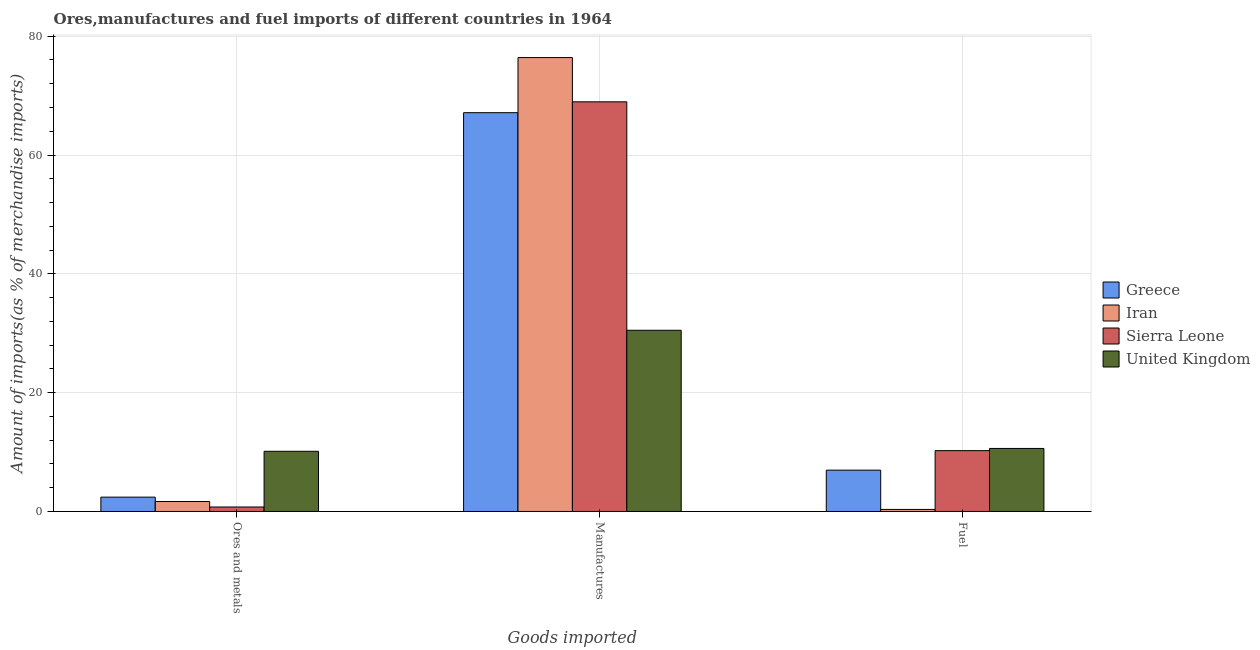How many different coloured bars are there?
Your answer should be compact. 4. How many groups of bars are there?
Your response must be concise. 3. How many bars are there on the 2nd tick from the left?
Your answer should be very brief. 4. How many bars are there on the 2nd tick from the right?
Your response must be concise. 4. What is the label of the 2nd group of bars from the left?
Provide a short and direct response. Manufactures. What is the percentage of fuel imports in Sierra Leone?
Provide a succinct answer. 10.24. Across all countries, what is the maximum percentage of fuel imports?
Provide a succinct answer. 10.61. Across all countries, what is the minimum percentage of manufactures imports?
Offer a very short reply. 30.5. In which country was the percentage of ores and metals imports minimum?
Offer a terse response. Sierra Leone. What is the total percentage of manufactures imports in the graph?
Offer a terse response. 243. What is the difference between the percentage of fuel imports in United Kingdom and that in Greece?
Keep it short and to the point. 3.65. What is the difference between the percentage of fuel imports in Sierra Leone and the percentage of ores and metals imports in United Kingdom?
Make the answer very short. 0.11. What is the average percentage of fuel imports per country?
Your answer should be very brief. 7.04. What is the difference between the percentage of manufactures imports and percentage of fuel imports in Iran?
Offer a terse response. 76.06. What is the ratio of the percentage of ores and metals imports in Greece to that in United Kingdom?
Your answer should be compact. 0.24. Is the percentage of fuel imports in Greece less than that in Iran?
Your answer should be very brief. No. Is the difference between the percentage of fuel imports in United Kingdom and Greece greater than the difference between the percentage of ores and metals imports in United Kingdom and Greece?
Make the answer very short. No. What is the difference between the highest and the second highest percentage of ores and metals imports?
Provide a succinct answer. 7.72. What is the difference between the highest and the lowest percentage of manufactures imports?
Your answer should be very brief. 45.9. What does the 4th bar from the left in Ores and metals represents?
Provide a succinct answer. United Kingdom. What does the 1st bar from the right in Ores and metals represents?
Provide a succinct answer. United Kingdom. Is it the case that in every country, the sum of the percentage of ores and metals imports and percentage of manufactures imports is greater than the percentage of fuel imports?
Give a very brief answer. Yes. How many countries are there in the graph?
Provide a short and direct response. 4. What is the difference between two consecutive major ticks on the Y-axis?
Offer a terse response. 20. Are the values on the major ticks of Y-axis written in scientific E-notation?
Give a very brief answer. No. Does the graph contain any zero values?
Your response must be concise. No. Does the graph contain grids?
Your answer should be very brief. Yes. How are the legend labels stacked?
Your answer should be very brief. Vertical. What is the title of the graph?
Make the answer very short. Ores,manufactures and fuel imports of different countries in 1964. What is the label or title of the X-axis?
Offer a very short reply. Goods imported. What is the label or title of the Y-axis?
Ensure brevity in your answer.  Amount of imports(as % of merchandise imports). What is the Amount of imports(as % of merchandise imports) in Greece in Ores and metals?
Offer a very short reply. 2.42. What is the Amount of imports(as % of merchandise imports) in Iran in Ores and metals?
Provide a succinct answer. 1.68. What is the Amount of imports(as % of merchandise imports) in Sierra Leone in Ores and metals?
Your answer should be compact. 0.76. What is the Amount of imports(as % of merchandise imports) of United Kingdom in Ores and metals?
Give a very brief answer. 10.13. What is the Amount of imports(as % of merchandise imports) of Greece in Manufactures?
Your answer should be compact. 67.13. What is the Amount of imports(as % of merchandise imports) of Iran in Manufactures?
Offer a very short reply. 76.41. What is the Amount of imports(as % of merchandise imports) in Sierra Leone in Manufactures?
Ensure brevity in your answer.  68.96. What is the Amount of imports(as % of merchandise imports) in United Kingdom in Manufactures?
Your answer should be very brief. 30.5. What is the Amount of imports(as % of merchandise imports) in Greece in Fuel?
Your response must be concise. 6.96. What is the Amount of imports(as % of merchandise imports) in Iran in Fuel?
Give a very brief answer. 0.35. What is the Amount of imports(as % of merchandise imports) of Sierra Leone in Fuel?
Provide a succinct answer. 10.24. What is the Amount of imports(as % of merchandise imports) of United Kingdom in Fuel?
Your response must be concise. 10.61. Across all Goods imported, what is the maximum Amount of imports(as % of merchandise imports) of Greece?
Your answer should be very brief. 67.13. Across all Goods imported, what is the maximum Amount of imports(as % of merchandise imports) of Iran?
Keep it short and to the point. 76.41. Across all Goods imported, what is the maximum Amount of imports(as % of merchandise imports) of Sierra Leone?
Offer a terse response. 68.96. Across all Goods imported, what is the maximum Amount of imports(as % of merchandise imports) in United Kingdom?
Your response must be concise. 30.5. Across all Goods imported, what is the minimum Amount of imports(as % of merchandise imports) in Greece?
Ensure brevity in your answer.  2.42. Across all Goods imported, what is the minimum Amount of imports(as % of merchandise imports) of Iran?
Make the answer very short. 0.35. Across all Goods imported, what is the minimum Amount of imports(as % of merchandise imports) in Sierra Leone?
Provide a succinct answer. 0.76. Across all Goods imported, what is the minimum Amount of imports(as % of merchandise imports) of United Kingdom?
Offer a very short reply. 10.13. What is the total Amount of imports(as % of merchandise imports) of Greece in the graph?
Ensure brevity in your answer.  76.5. What is the total Amount of imports(as % of merchandise imports) in Iran in the graph?
Ensure brevity in your answer.  78.44. What is the total Amount of imports(as % of merchandise imports) in Sierra Leone in the graph?
Your answer should be very brief. 79.96. What is the total Amount of imports(as % of merchandise imports) of United Kingdom in the graph?
Your answer should be compact. 51.25. What is the difference between the Amount of imports(as % of merchandise imports) in Greece in Ores and metals and that in Manufactures?
Provide a short and direct response. -64.71. What is the difference between the Amount of imports(as % of merchandise imports) in Iran in Ores and metals and that in Manufactures?
Offer a very short reply. -74.72. What is the difference between the Amount of imports(as % of merchandise imports) of Sierra Leone in Ores and metals and that in Manufactures?
Provide a succinct answer. -68.2. What is the difference between the Amount of imports(as % of merchandise imports) of United Kingdom in Ores and metals and that in Manufactures?
Make the answer very short. -20.37. What is the difference between the Amount of imports(as % of merchandise imports) in Greece in Ores and metals and that in Fuel?
Offer a very short reply. -4.54. What is the difference between the Amount of imports(as % of merchandise imports) in Iran in Ores and metals and that in Fuel?
Your response must be concise. 1.34. What is the difference between the Amount of imports(as % of merchandise imports) of Sierra Leone in Ores and metals and that in Fuel?
Provide a succinct answer. -9.49. What is the difference between the Amount of imports(as % of merchandise imports) of United Kingdom in Ores and metals and that in Fuel?
Offer a terse response. -0.48. What is the difference between the Amount of imports(as % of merchandise imports) of Greece in Manufactures and that in Fuel?
Make the answer very short. 60.17. What is the difference between the Amount of imports(as % of merchandise imports) of Iran in Manufactures and that in Fuel?
Your response must be concise. 76.06. What is the difference between the Amount of imports(as % of merchandise imports) in Sierra Leone in Manufactures and that in Fuel?
Keep it short and to the point. 58.72. What is the difference between the Amount of imports(as % of merchandise imports) of United Kingdom in Manufactures and that in Fuel?
Your answer should be compact. 19.89. What is the difference between the Amount of imports(as % of merchandise imports) of Greece in Ores and metals and the Amount of imports(as % of merchandise imports) of Iran in Manufactures?
Ensure brevity in your answer.  -73.99. What is the difference between the Amount of imports(as % of merchandise imports) in Greece in Ores and metals and the Amount of imports(as % of merchandise imports) in Sierra Leone in Manufactures?
Give a very brief answer. -66.54. What is the difference between the Amount of imports(as % of merchandise imports) in Greece in Ores and metals and the Amount of imports(as % of merchandise imports) in United Kingdom in Manufactures?
Provide a short and direct response. -28.09. What is the difference between the Amount of imports(as % of merchandise imports) of Iran in Ores and metals and the Amount of imports(as % of merchandise imports) of Sierra Leone in Manufactures?
Offer a terse response. -67.27. What is the difference between the Amount of imports(as % of merchandise imports) in Iran in Ores and metals and the Amount of imports(as % of merchandise imports) in United Kingdom in Manufactures?
Offer a very short reply. -28.82. What is the difference between the Amount of imports(as % of merchandise imports) of Sierra Leone in Ores and metals and the Amount of imports(as % of merchandise imports) of United Kingdom in Manufactures?
Keep it short and to the point. -29.75. What is the difference between the Amount of imports(as % of merchandise imports) of Greece in Ores and metals and the Amount of imports(as % of merchandise imports) of Iran in Fuel?
Give a very brief answer. 2.07. What is the difference between the Amount of imports(as % of merchandise imports) in Greece in Ores and metals and the Amount of imports(as % of merchandise imports) in Sierra Leone in Fuel?
Your answer should be very brief. -7.83. What is the difference between the Amount of imports(as % of merchandise imports) in Greece in Ores and metals and the Amount of imports(as % of merchandise imports) in United Kingdom in Fuel?
Your answer should be very brief. -8.19. What is the difference between the Amount of imports(as % of merchandise imports) of Iran in Ores and metals and the Amount of imports(as % of merchandise imports) of Sierra Leone in Fuel?
Your answer should be compact. -8.56. What is the difference between the Amount of imports(as % of merchandise imports) in Iran in Ores and metals and the Amount of imports(as % of merchandise imports) in United Kingdom in Fuel?
Keep it short and to the point. -8.93. What is the difference between the Amount of imports(as % of merchandise imports) of Sierra Leone in Ores and metals and the Amount of imports(as % of merchandise imports) of United Kingdom in Fuel?
Offer a very short reply. -9.85. What is the difference between the Amount of imports(as % of merchandise imports) of Greece in Manufactures and the Amount of imports(as % of merchandise imports) of Iran in Fuel?
Offer a terse response. 66.78. What is the difference between the Amount of imports(as % of merchandise imports) in Greece in Manufactures and the Amount of imports(as % of merchandise imports) in Sierra Leone in Fuel?
Provide a succinct answer. 56.89. What is the difference between the Amount of imports(as % of merchandise imports) in Greece in Manufactures and the Amount of imports(as % of merchandise imports) in United Kingdom in Fuel?
Provide a succinct answer. 56.52. What is the difference between the Amount of imports(as % of merchandise imports) in Iran in Manufactures and the Amount of imports(as % of merchandise imports) in Sierra Leone in Fuel?
Provide a succinct answer. 66.16. What is the difference between the Amount of imports(as % of merchandise imports) of Iran in Manufactures and the Amount of imports(as % of merchandise imports) of United Kingdom in Fuel?
Your response must be concise. 65.8. What is the difference between the Amount of imports(as % of merchandise imports) of Sierra Leone in Manufactures and the Amount of imports(as % of merchandise imports) of United Kingdom in Fuel?
Make the answer very short. 58.35. What is the average Amount of imports(as % of merchandise imports) in Greece per Goods imported?
Keep it short and to the point. 25.5. What is the average Amount of imports(as % of merchandise imports) of Iran per Goods imported?
Your answer should be very brief. 26.15. What is the average Amount of imports(as % of merchandise imports) in Sierra Leone per Goods imported?
Keep it short and to the point. 26.65. What is the average Amount of imports(as % of merchandise imports) of United Kingdom per Goods imported?
Make the answer very short. 17.08. What is the difference between the Amount of imports(as % of merchandise imports) of Greece and Amount of imports(as % of merchandise imports) of Iran in Ores and metals?
Make the answer very short. 0.73. What is the difference between the Amount of imports(as % of merchandise imports) in Greece and Amount of imports(as % of merchandise imports) in Sierra Leone in Ores and metals?
Offer a terse response. 1.66. What is the difference between the Amount of imports(as % of merchandise imports) in Greece and Amount of imports(as % of merchandise imports) in United Kingdom in Ores and metals?
Provide a short and direct response. -7.72. What is the difference between the Amount of imports(as % of merchandise imports) of Iran and Amount of imports(as % of merchandise imports) of Sierra Leone in Ores and metals?
Provide a short and direct response. 0.93. What is the difference between the Amount of imports(as % of merchandise imports) in Iran and Amount of imports(as % of merchandise imports) in United Kingdom in Ores and metals?
Your answer should be very brief. -8.45. What is the difference between the Amount of imports(as % of merchandise imports) of Sierra Leone and Amount of imports(as % of merchandise imports) of United Kingdom in Ores and metals?
Give a very brief answer. -9.38. What is the difference between the Amount of imports(as % of merchandise imports) of Greece and Amount of imports(as % of merchandise imports) of Iran in Manufactures?
Your answer should be compact. -9.28. What is the difference between the Amount of imports(as % of merchandise imports) of Greece and Amount of imports(as % of merchandise imports) of Sierra Leone in Manufactures?
Offer a very short reply. -1.83. What is the difference between the Amount of imports(as % of merchandise imports) in Greece and Amount of imports(as % of merchandise imports) in United Kingdom in Manufactures?
Provide a succinct answer. 36.63. What is the difference between the Amount of imports(as % of merchandise imports) of Iran and Amount of imports(as % of merchandise imports) of Sierra Leone in Manufactures?
Provide a short and direct response. 7.45. What is the difference between the Amount of imports(as % of merchandise imports) in Iran and Amount of imports(as % of merchandise imports) in United Kingdom in Manufactures?
Offer a terse response. 45.9. What is the difference between the Amount of imports(as % of merchandise imports) of Sierra Leone and Amount of imports(as % of merchandise imports) of United Kingdom in Manufactures?
Provide a succinct answer. 38.46. What is the difference between the Amount of imports(as % of merchandise imports) in Greece and Amount of imports(as % of merchandise imports) in Iran in Fuel?
Offer a very short reply. 6.61. What is the difference between the Amount of imports(as % of merchandise imports) in Greece and Amount of imports(as % of merchandise imports) in Sierra Leone in Fuel?
Make the answer very short. -3.28. What is the difference between the Amount of imports(as % of merchandise imports) in Greece and Amount of imports(as % of merchandise imports) in United Kingdom in Fuel?
Provide a short and direct response. -3.65. What is the difference between the Amount of imports(as % of merchandise imports) of Iran and Amount of imports(as % of merchandise imports) of Sierra Leone in Fuel?
Provide a succinct answer. -9.89. What is the difference between the Amount of imports(as % of merchandise imports) in Iran and Amount of imports(as % of merchandise imports) in United Kingdom in Fuel?
Your answer should be compact. -10.26. What is the difference between the Amount of imports(as % of merchandise imports) of Sierra Leone and Amount of imports(as % of merchandise imports) of United Kingdom in Fuel?
Your answer should be very brief. -0.37. What is the ratio of the Amount of imports(as % of merchandise imports) in Greece in Ores and metals to that in Manufactures?
Your answer should be very brief. 0.04. What is the ratio of the Amount of imports(as % of merchandise imports) in Iran in Ores and metals to that in Manufactures?
Keep it short and to the point. 0.02. What is the ratio of the Amount of imports(as % of merchandise imports) of Sierra Leone in Ores and metals to that in Manufactures?
Make the answer very short. 0.01. What is the ratio of the Amount of imports(as % of merchandise imports) of United Kingdom in Ores and metals to that in Manufactures?
Provide a short and direct response. 0.33. What is the ratio of the Amount of imports(as % of merchandise imports) in Greece in Ores and metals to that in Fuel?
Make the answer very short. 0.35. What is the ratio of the Amount of imports(as % of merchandise imports) in Iran in Ores and metals to that in Fuel?
Keep it short and to the point. 4.85. What is the ratio of the Amount of imports(as % of merchandise imports) in Sierra Leone in Ores and metals to that in Fuel?
Make the answer very short. 0.07. What is the ratio of the Amount of imports(as % of merchandise imports) of United Kingdom in Ores and metals to that in Fuel?
Provide a succinct answer. 0.96. What is the ratio of the Amount of imports(as % of merchandise imports) of Greece in Manufactures to that in Fuel?
Keep it short and to the point. 9.65. What is the ratio of the Amount of imports(as % of merchandise imports) of Iran in Manufactures to that in Fuel?
Provide a short and direct response. 220.12. What is the ratio of the Amount of imports(as % of merchandise imports) of Sierra Leone in Manufactures to that in Fuel?
Your answer should be very brief. 6.73. What is the ratio of the Amount of imports(as % of merchandise imports) in United Kingdom in Manufactures to that in Fuel?
Make the answer very short. 2.87. What is the difference between the highest and the second highest Amount of imports(as % of merchandise imports) of Greece?
Offer a very short reply. 60.17. What is the difference between the highest and the second highest Amount of imports(as % of merchandise imports) of Iran?
Offer a terse response. 74.72. What is the difference between the highest and the second highest Amount of imports(as % of merchandise imports) of Sierra Leone?
Keep it short and to the point. 58.72. What is the difference between the highest and the second highest Amount of imports(as % of merchandise imports) in United Kingdom?
Provide a short and direct response. 19.89. What is the difference between the highest and the lowest Amount of imports(as % of merchandise imports) of Greece?
Give a very brief answer. 64.71. What is the difference between the highest and the lowest Amount of imports(as % of merchandise imports) of Iran?
Ensure brevity in your answer.  76.06. What is the difference between the highest and the lowest Amount of imports(as % of merchandise imports) in Sierra Leone?
Provide a short and direct response. 68.2. What is the difference between the highest and the lowest Amount of imports(as % of merchandise imports) of United Kingdom?
Keep it short and to the point. 20.37. 